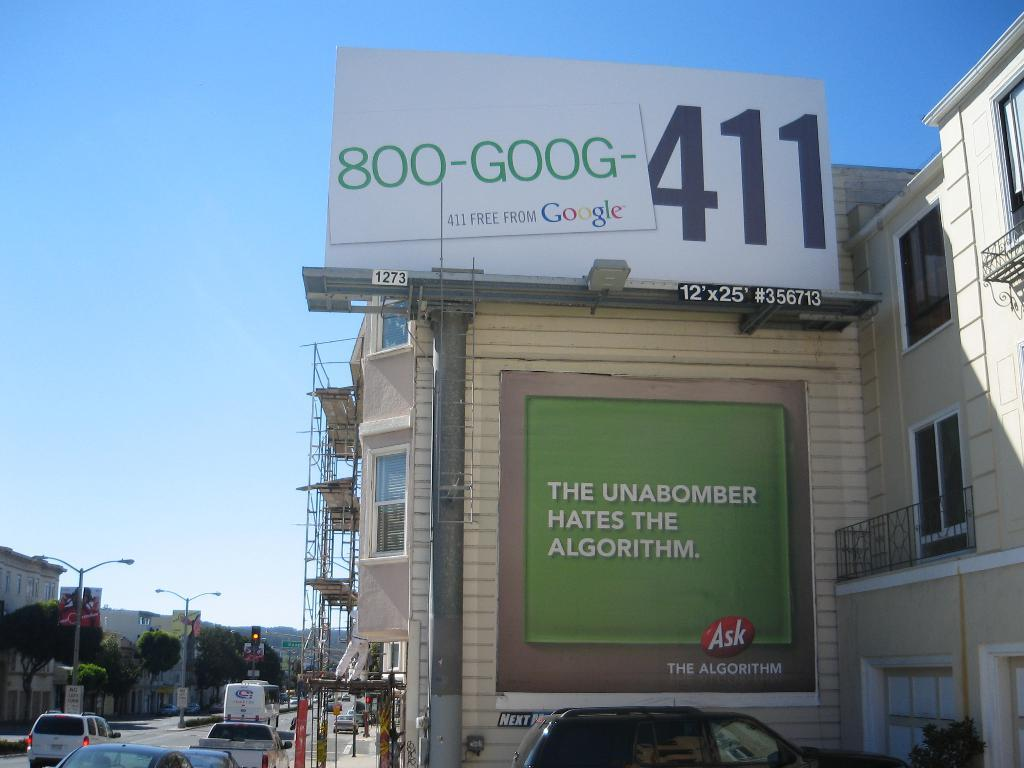<image>
Relay a brief, clear account of the picture shown. A street shot with a green sign by Ask 